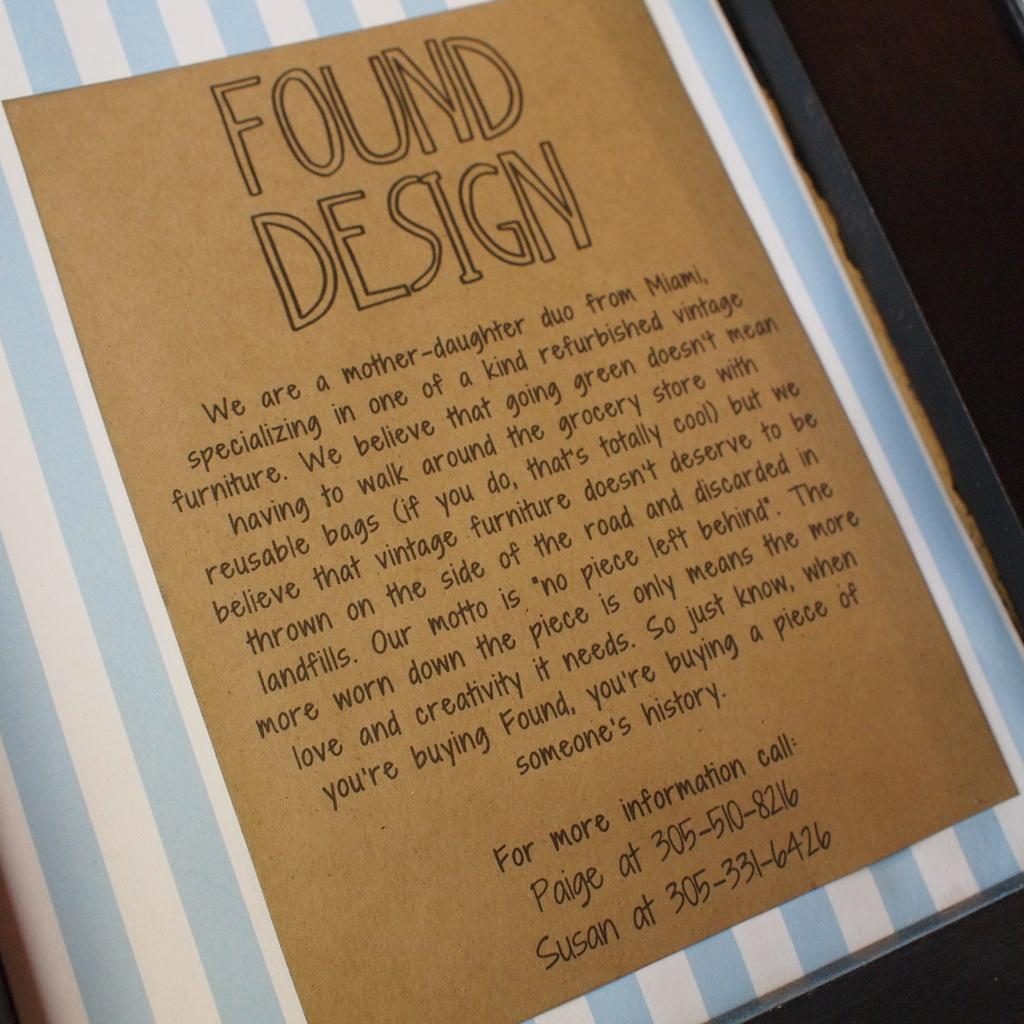<image>
Offer a succinct explanation of the picture presented. A blue and white striped book cover with a title of Found Design. 